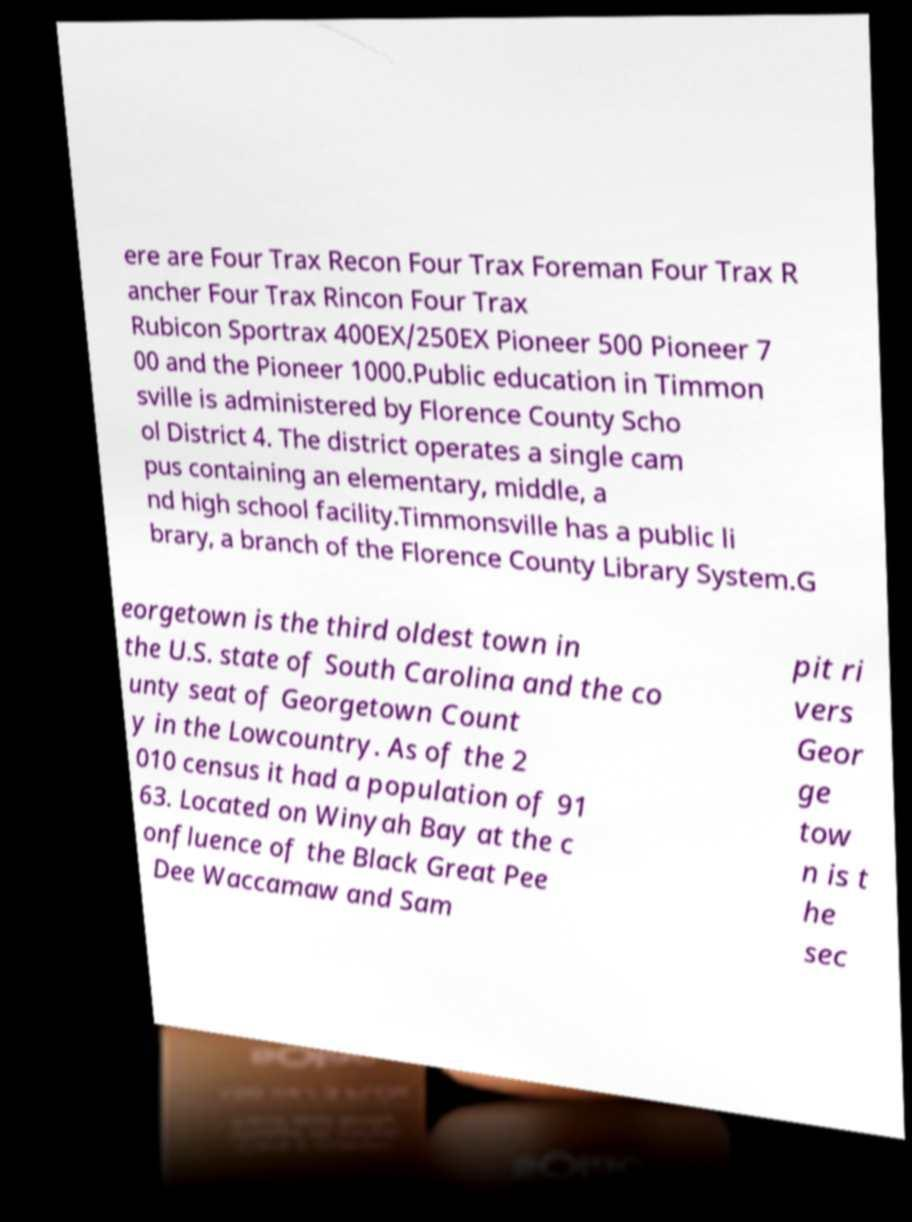Please identify and transcribe the text found in this image. ere are Four Trax Recon Four Trax Foreman Four Trax R ancher Four Trax Rincon Four Trax Rubicon Sportrax 400EX/250EX Pioneer 500 Pioneer 7 00 and the Pioneer 1000.Public education in Timmon sville is administered by Florence County Scho ol District 4. The district operates a single cam pus containing an elementary, middle, a nd high school facility.Timmonsville has a public li brary, a branch of the Florence County Library System.G eorgetown is the third oldest town in the U.S. state of South Carolina and the co unty seat of Georgetown Count y in the Lowcountry. As of the 2 010 census it had a population of 91 63. Located on Winyah Bay at the c onfluence of the Black Great Pee Dee Waccamaw and Sam pit ri vers Geor ge tow n is t he sec 